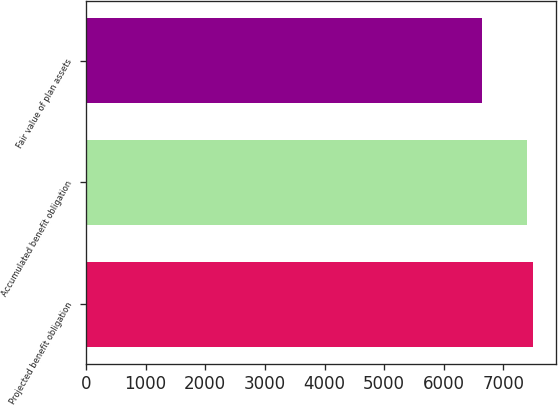Convert chart. <chart><loc_0><loc_0><loc_500><loc_500><bar_chart><fcel>Projected benefit obligation<fcel>Accumulated benefit obligation<fcel>Fair value of plan assets<nl><fcel>7499<fcel>7395<fcel>6646<nl></chart> 